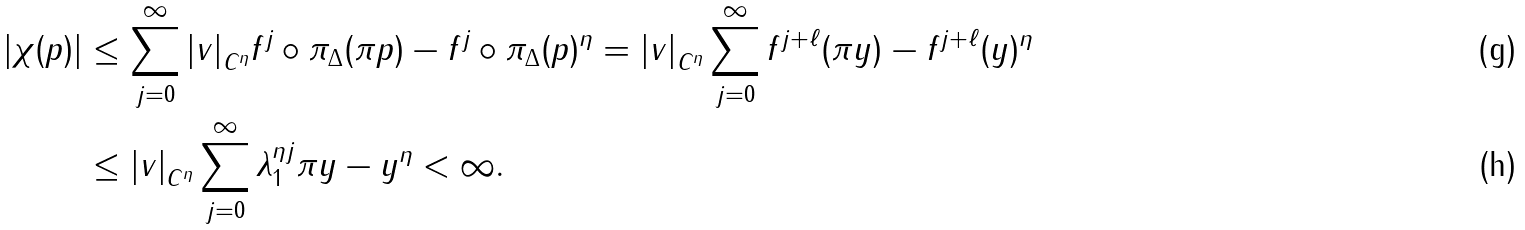<formula> <loc_0><loc_0><loc_500><loc_500>| \chi ( p ) | & \leq \sum _ { j = 0 } ^ { \infty } { | v | } _ { C ^ { \eta } } \| f ^ { j } \circ \pi _ { \Delta } ( \pi p ) - f ^ { j } \circ \pi _ { \Delta } ( p ) \| ^ { \eta } = { | v | } _ { C ^ { \eta } } \sum _ { j = 0 } ^ { \infty } \| f ^ { j + \ell } ( \pi y ) - f ^ { j + \ell } ( y ) \| ^ { \eta } \\ & \leq { | v | } _ { C ^ { \eta } } \sum _ { j = 0 } ^ { \infty } \lambda _ { 1 } ^ { \eta j } \| \pi y - y \| ^ { \eta } < \infty .</formula> 